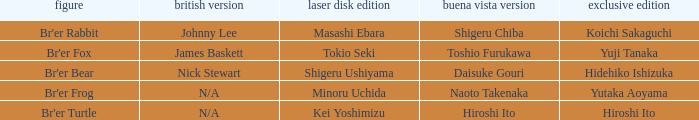What is the english version that is buena vista edition is daisuke gouri? Nick Stewart. 